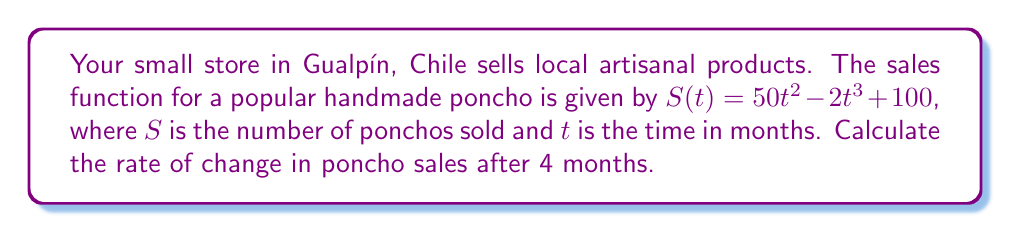Provide a solution to this math problem. To find the rate of change in poncho sales after 4 months, we need to calculate the derivative of the sales function $S(t)$ and evaluate it at $t=4$.

Step 1: Find the derivative of $S(t)$
$$\frac{d}{dt}S(t) = \frac{d}{dt}(50t^2 - 2t^3 + 100)$$
$$S'(t) = 100t - 6t^2$$

Step 2: Evaluate $S'(t)$ at $t=4$
$$S'(4) = 100(4) - 6(4)^2$$
$$S'(4) = 400 - 6(16)$$
$$S'(4) = 400 - 96$$
$$S'(4) = 304$$

The rate of change in poncho sales after 4 months is 304 ponchos per month.
Answer: 304 ponchos/month 